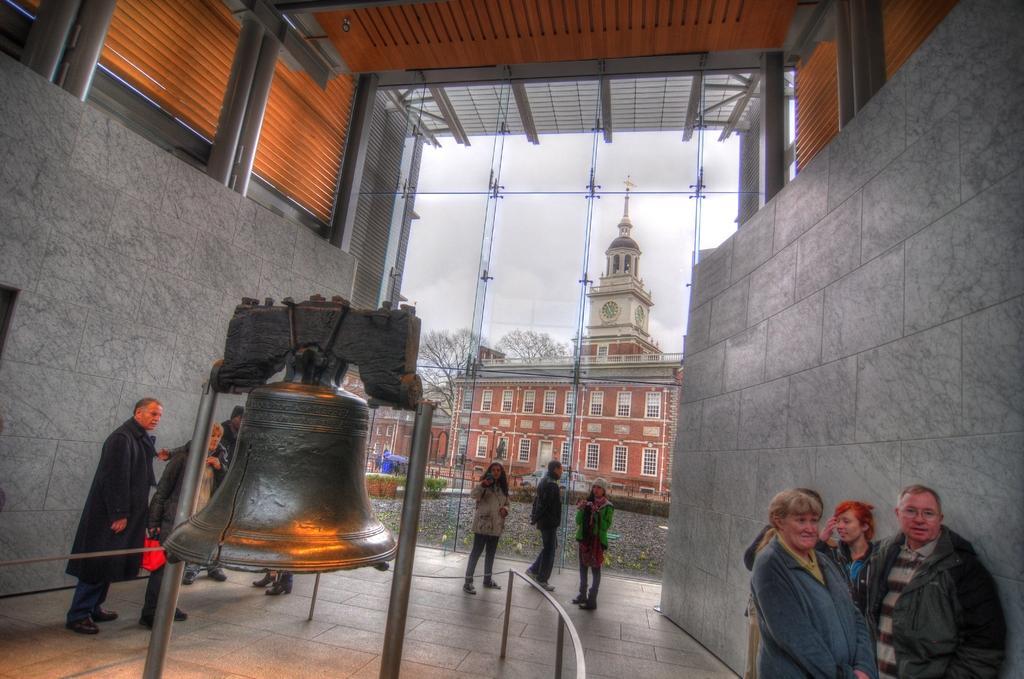Can you describe this image briefly? This image consists of building in the middle. There are trees in the middle. There is a bell in the middle. There are some persons standing in the middle. 